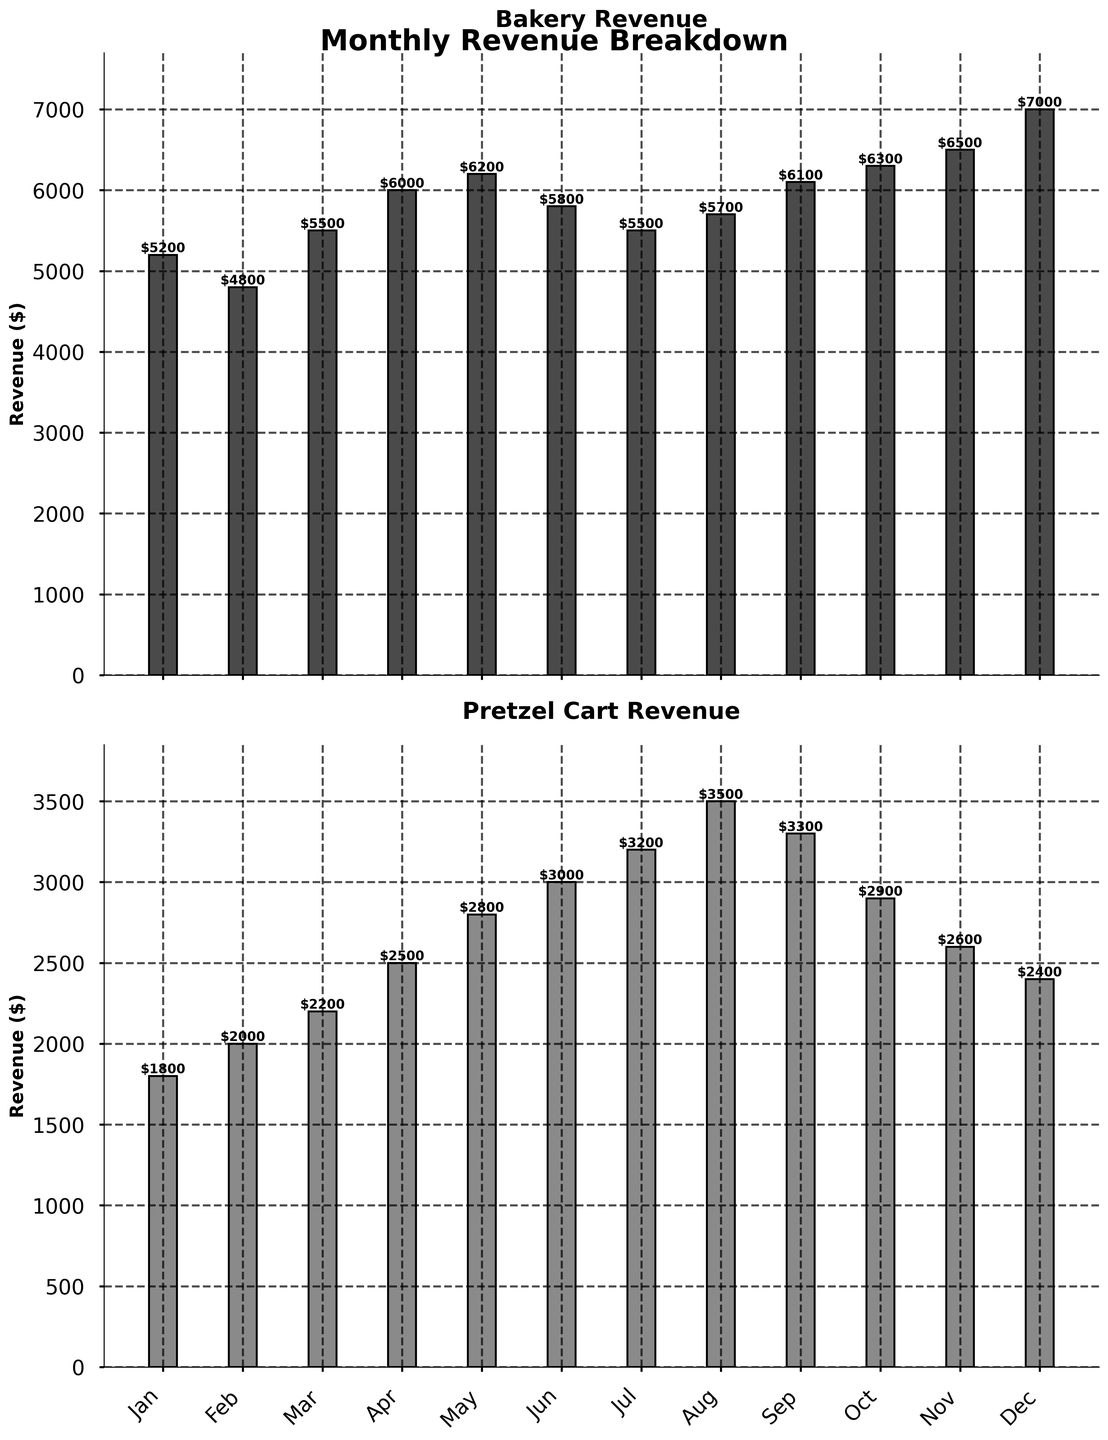What is the highest revenue month for the bakery? By looking at the bar heights in the Bakery Revenue plot, the tallest bar represents December, indicating it has the highest revenue.
Answer: December What is the difference in revenue between May and October for the pretzel cart? Locate the bars for May and October in the Pretzel Cart Revenue plot. May's revenue is $2800 and October's revenue is $2900. The difference is $2900 - $2800.
Answer: $100 What is the average monthly revenue for the bakery over the year? Summing up all bakery revenues: $5200 + $4800 + $5500 + $6000 + $6200 + $5800 + $5500 + $5700 + $6100 + $6300 + $6500 + $7000 = $71600. There are 12 months, so the average is $71600 / 12.
Answer: $5966.67 Which month shows the smallest revenue for the pretzel cart and what is its value? By comparing the bar heights in the Pretzel Cart Revenue plot, January has the smallest bar, and its value is $1800.
Answer: January, $1800 How much higher is the bakery's revenue compared to the pretzel cart's highest revenue month? The highest revenue for the bakery is December ($7000), and the highest for the pretzel cart is August ($3500). The difference is $7000 - $3500.
Answer: $3500 In which months is the pretzel cart revenue greater than $3000? By identifying the bars that exceed $3000 in the Pretzel Cart Revenue plot, the months are June, July, August, and September.
Answer: June, July, August, September What is the total revenue for the bakery and pretzel cart combined in March? March revenues are $5500 (bakery) and $2200 (pretzel cart). The total combined revenue is $5500 + $2200.
Answer: $7700 During which month(s) does the bakery revenue exceed $6000? By identifying the bars higher than $6000 in the Bakery Revenue plot, the months are October, November, and December.
Answer: October, November, December In which month is the difference between bakery revenue and pretzel cart revenue the largest? Calculate the differences for each month and compare:
- Jan: $5200 - $1800 = $3400
- Feb: $4800 - $2000 = $2800
- Mar: $5500 - $2200 = $3300
- Apr: $6000 - $2500 = $3500
- May: $6200 - $2800 = $3400
- Jun: $5800 - $3000 = $2800
- Jul: $5500 - $3200 = $2300
- Aug: $5700 - $3500 = $2200
- Sep: $6100 - $3300 = $2800
- Oct: $6300 - $2900 = $3400
- Nov: $6500 - $2600 = $3900
- Dec: $7000 - $2400 = $4600
The largest difference is in December.
Answer: December 